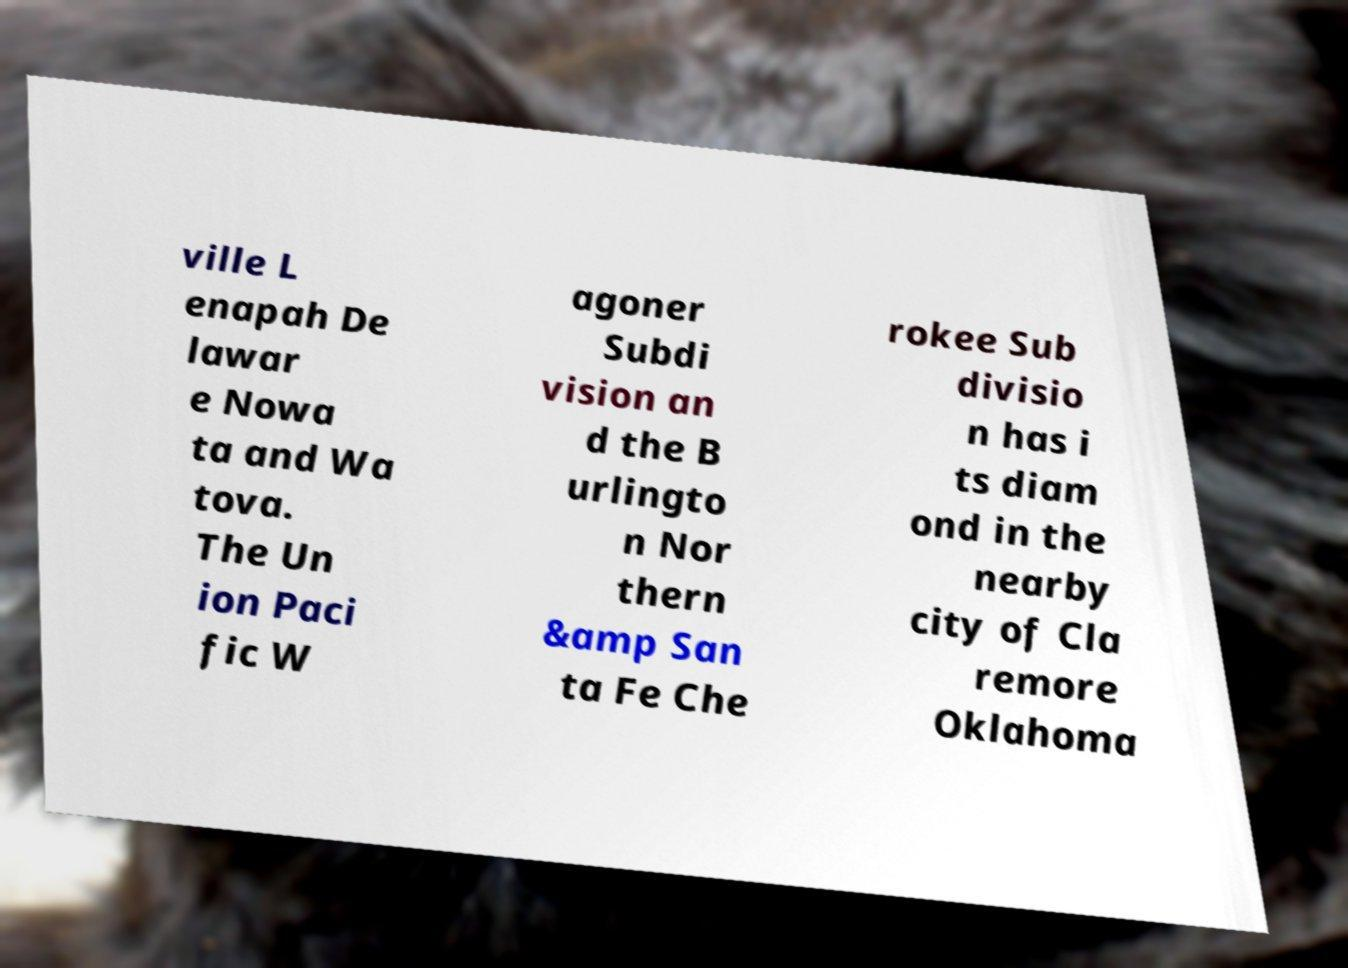Could you assist in decoding the text presented in this image and type it out clearly? ville L enapah De lawar e Nowa ta and Wa tova. The Un ion Paci fic W agoner Subdi vision an d the B urlingto n Nor thern &amp San ta Fe Che rokee Sub divisio n has i ts diam ond in the nearby city of Cla remore Oklahoma 